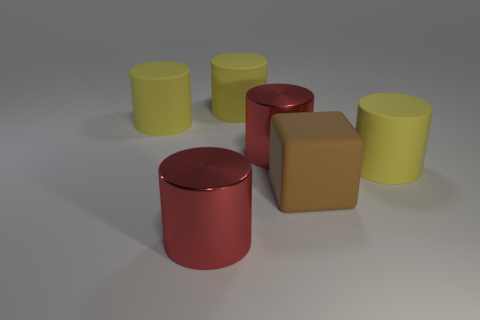Subtract all yellow cylinders. How many were subtracted if there are1yellow cylinders left? 2 Subtract all yellow cubes. How many yellow cylinders are left? 3 Subtract all red metallic cylinders. How many cylinders are left? 3 Add 3 tiny red balls. How many objects exist? 9 Subtract all red cylinders. How many cylinders are left? 3 Subtract all blue cylinders. Subtract all brown blocks. How many cylinders are left? 5 Subtract 0 gray cubes. How many objects are left? 6 Subtract all cylinders. How many objects are left? 1 Subtract all big rubber cylinders. Subtract all large brown things. How many objects are left? 2 Add 3 matte objects. How many matte objects are left? 7 